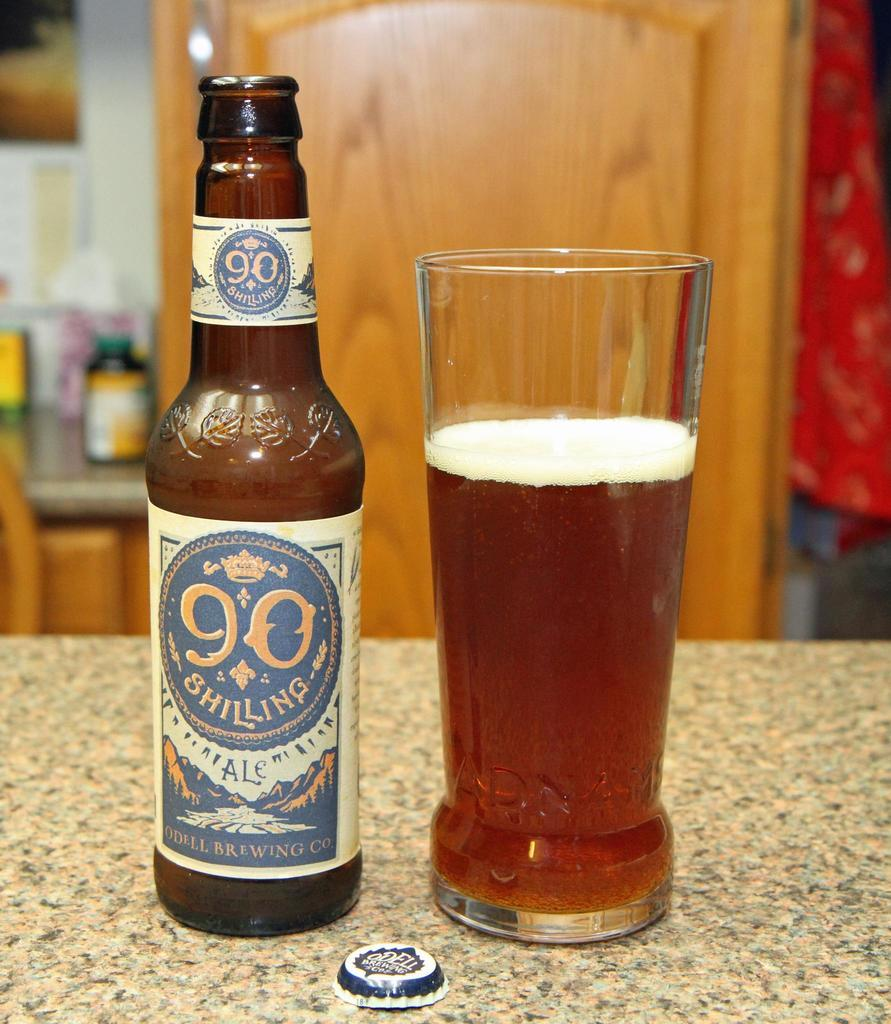What type of beverage is present in the image? There is beer in the image, both in a bottle and poured into a glass. Where are the bottle and glass located? Both the bottle and glass are on a table. What can be seen in the background of the image? There is a wooden door in the background of the image. What time is displayed on the clock in the image? There is no clock present in the image. How does the glass get burned in the image? The glass does not get burned in the image; it is holding beer and is not exposed to any heat source. 